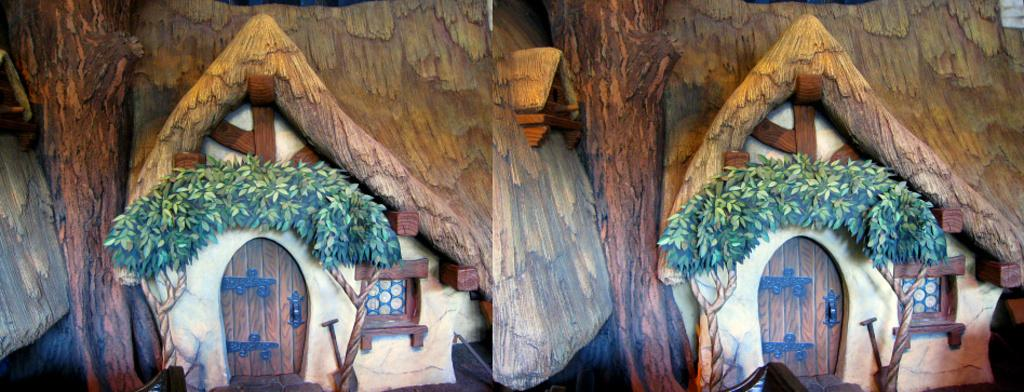What type of image is being described? The image is a collage. What is the main subject of the collage? There is an entrance view of a wooden house in the image. What feature of the wooden house is mentioned? There is a door in the wooden house. How are the leaves used in the image? Leaves are decorating the top of the door. How many cars are parked in front of the wooden house in the image? There is no mention of cars in the image; it only describes a wooden house with a door decorated with leaves. 